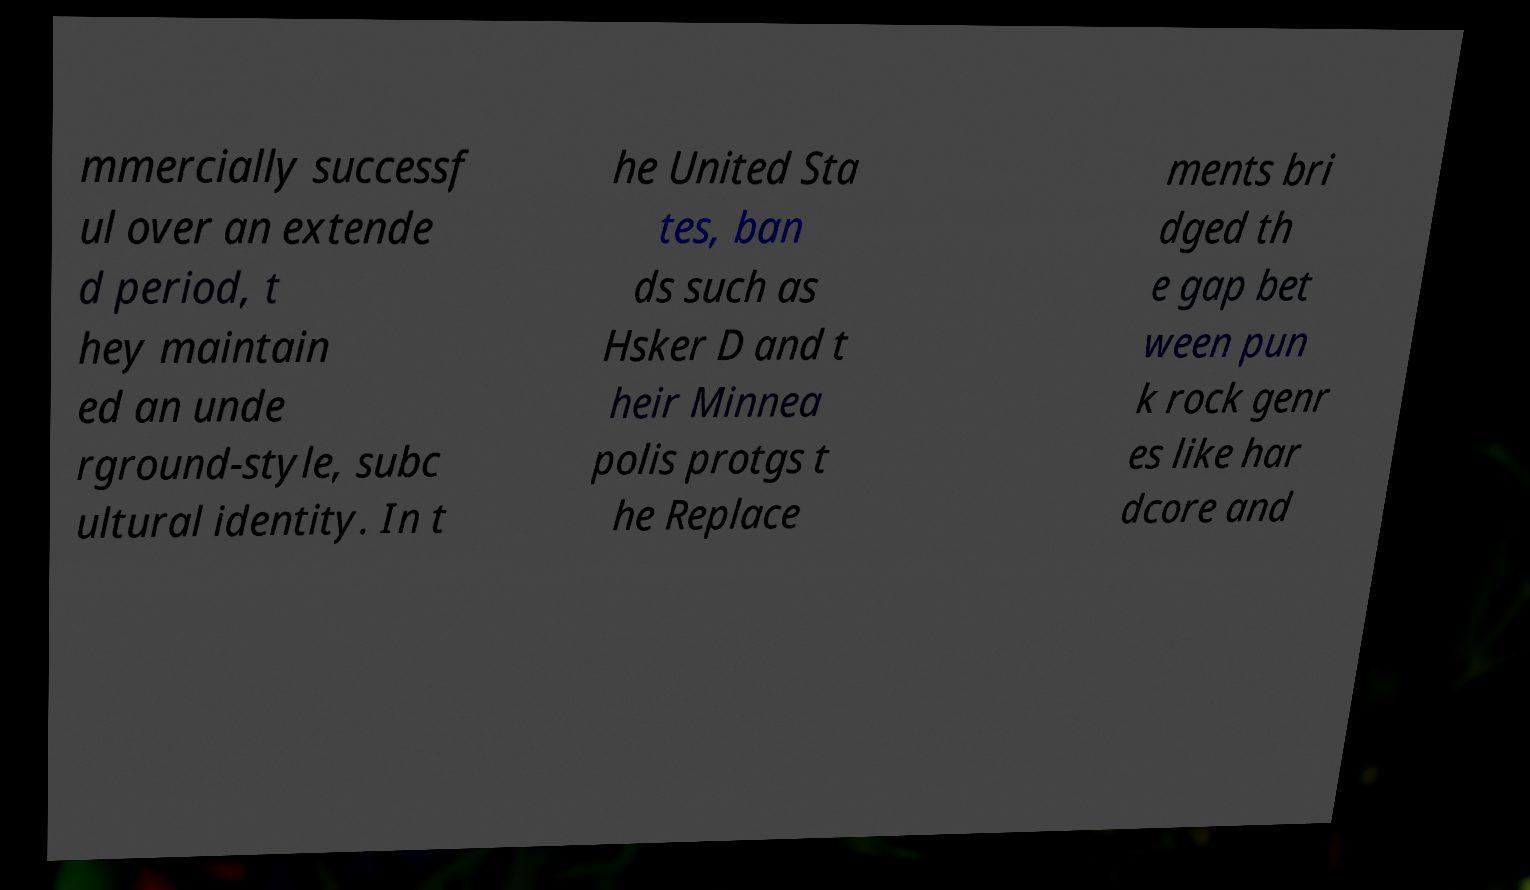For documentation purposes, I need the text within this image transcribed. Could you provide that? mmercially successf ul over an extende d period, t hey maintain ed an unde rground-style, subc ultural identity. In t he United Sta tes, ban ds such as Hsker D and t heir Minnea polis protgs t he Replace ments bri dged th e gap bet ween pun k rock genr es like har dcore and 